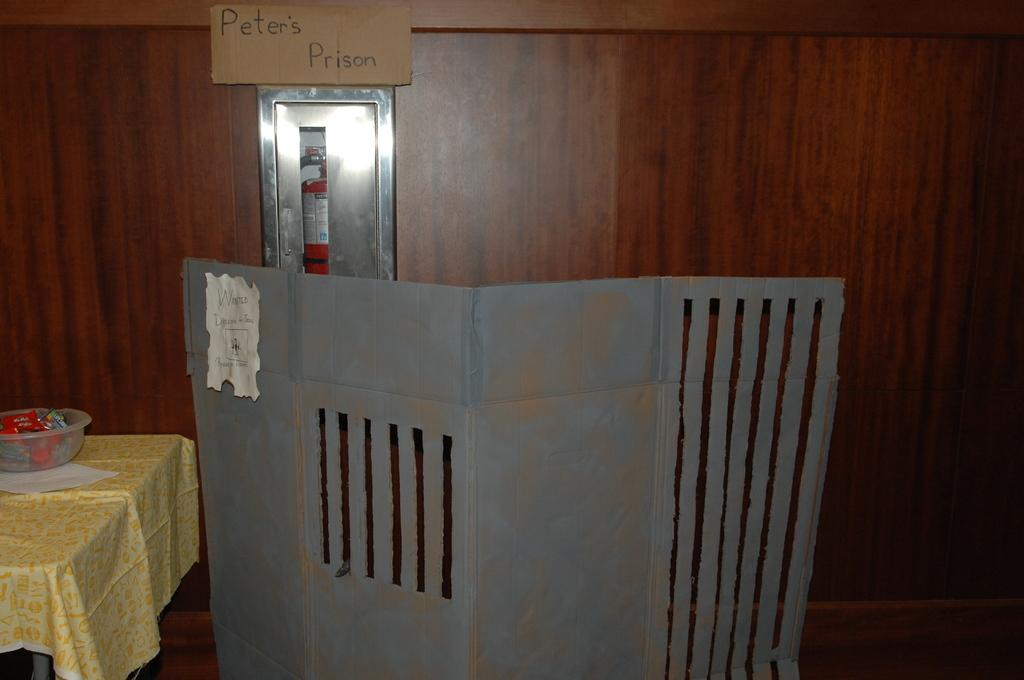<image>
Render a clear and concise summary of the photo. The cardboard prison appears to belong to a person called Peter. 